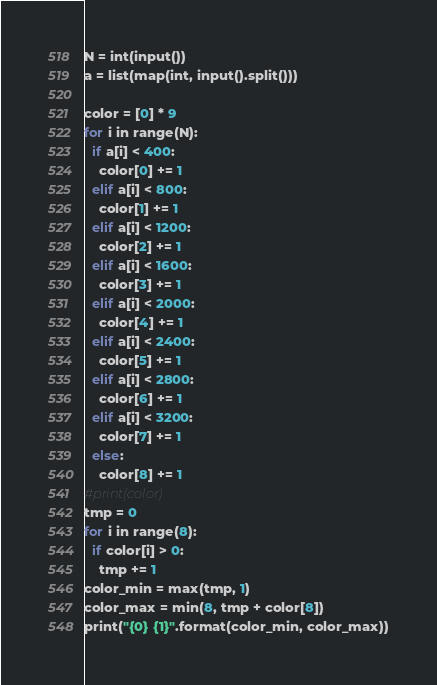Convert code to text. <code><loc_0><loc_0><loc_500><loc_500><_Python_>N = int(input())
a = list(map(int, input().split()))

color = [0] * 9
for i in range(N):
  if a[i] < 400:
    color[0] += 1
  elif a[i] < 800:
    color[1] += 1
  elif a[i] < 1200:
    color[2] += 1
  elif a[i] < 1600:
    color[3] += 1
  elif a[i] < 2000:
    color[4] += 1
  elif a[i] < 2400:
    color[5] += 1
  elif a[i] < 2800:
    color[6] += 1
  elif a[i] < 3200:
    color[7] += 1
  else:
    color[8] += 1
#print(color)
tmp = 0
for i in range(8):
  if color[i] > 0:
    tmp += 1
color_min = max(tmp, 1)
color_max = min(8, tmp + color[8])
print("{0} {1}".format(color_min, color_max))</code> 